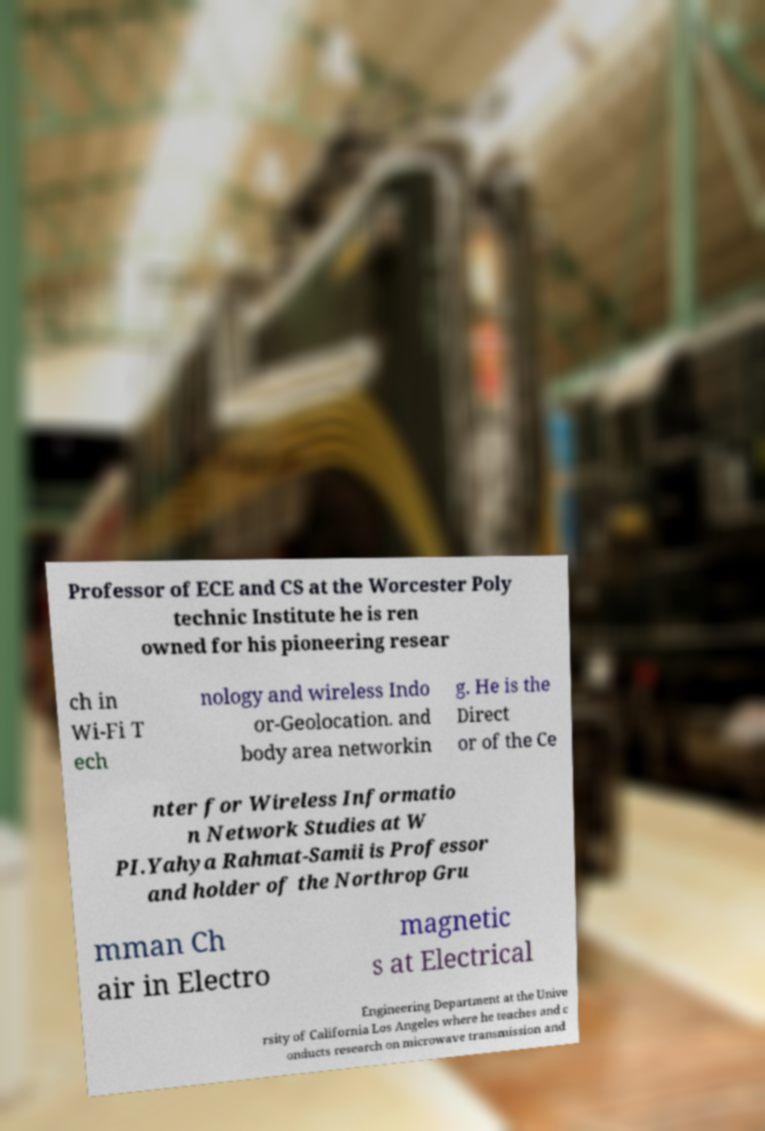What messages or text are displayed in this image? I need them in a readable, typed format. Professor of ECE and CS at the Worcester Poly technic Institute he is ren owned for his pioneering resear ch in Wi-Fi T ech nology and wireless Indo or-Geolocation. and body area networkin g. He is the Direct or of the Ce nter for Wireless Informatio n Network Studies at W PI.Yahya Rahmat-Samii is Professor and holder of the Northrop Gru mman Ch air in Electro magnetic s at Electrical Engineering Department at the Unive rsity of California Los Angeles where he teaches and c onducts research on microwave transmission and 